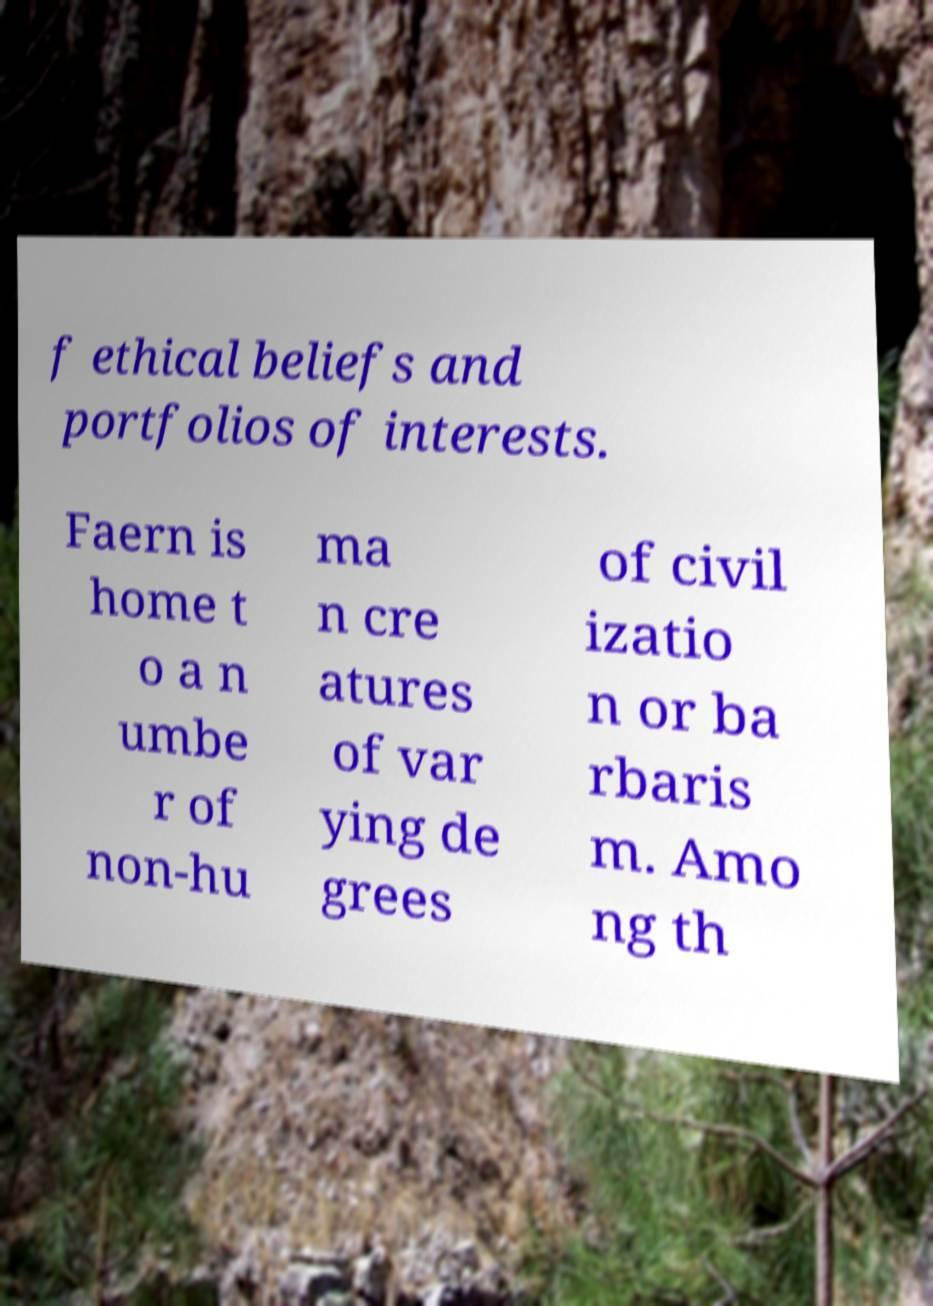I need the written content from this picture converted into text. Can you do that? f ethical beliefs and portfolios of interests. Faern is home t o a n umbe r of non-hu ma n cre atures of var ying de grees of civil izatio n or ba rbaris m. Amo ng th 